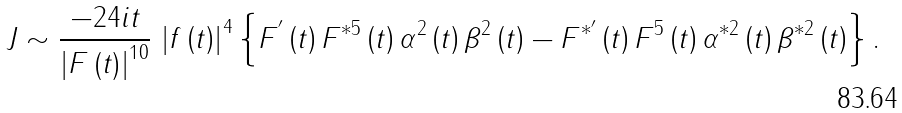Convert formula to latex. <formula><loc_0><loc_0><loc_500><loc_500>J \sim \frac { - 2 4 i t } { \left | F \left ( t \right ) \right | ^ { 1 0 } } \, \left | f \left ( t \right ) \right | ^ { 4 } \left \{ F ^ { ^ { \prime } } \left ( t \right ) F ^ { * 5 } \left ( t \right ) \alpha ^ { 2 } \left ( t \right ) \beta ^ { 2 } \left ( t \right ) - F ^ { * ^ { \prime } } \left ( t \right ) F ^ { 5 } \left ( t \right ) \alpha ^ { * 2 } \left ( t \right ) \beta ^ { * 2 } \left ( t \right ) \right \} .</formula> 